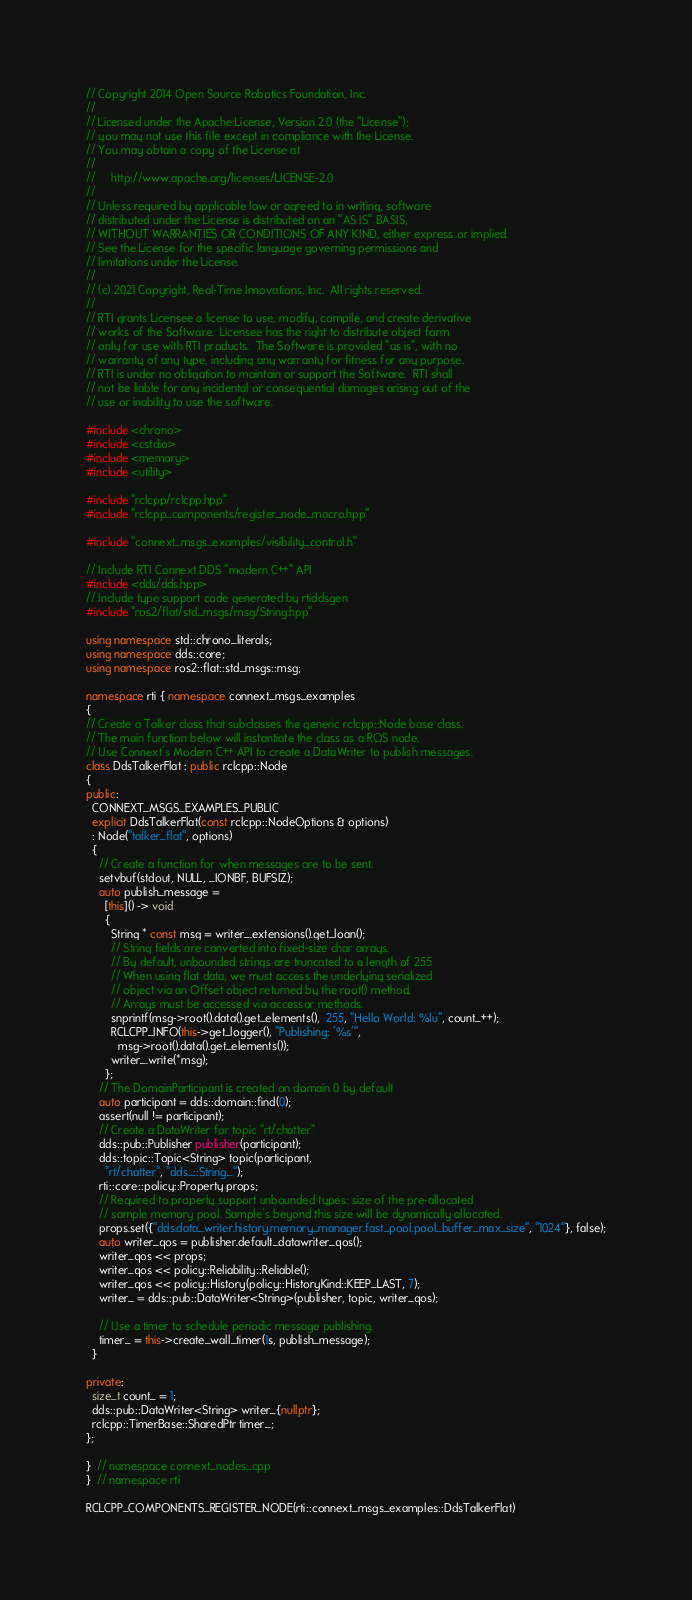<code> <loc_0><loc_0><loc_500><loc_500><_C++_>// Copyright 2014 Open Source Robotics Foundation, Inc.
//
// Licensed under the Apache License, Version 2.0 (the "License");
// you may not use this file except in compliance with the License.
// You may obtain a copy of the License at
//
//     http://www.apache.org/licenses/LICENSE-2.0
//
// Unless required by applicable law or agreed to in writing, software
// distributed under the License is distributed on an "AS IS" BASIS,
// WITHOUT WARRANTIES OR CONDITIONS OF ANY KIND, either express or implied.
// See the License for the specific language governing permissions and
// limitations under the License.
//
// (c) 2021 Copyright, Real-Time Innovations, Inc.  All rights reserved.
//
// RTI grants Licensee a license to use, modify, compile, and create derivative
// works of the Software.  Licensee has the right to distribute object form
// only for use with RTI products.  The Software is provided "as is", with no
// warranty of any type, including any warranty for fitness for any purpose.
// RTI is under no obligation to maintain or support the Software.  RTI shall
// not be liable for any incidental or consequential damages arising out of the
// use or inability to use the software.

#include <chrono>
#include <cstdio>
#include <memory>
#include <utility>

#include "rclcpp/rclcpp.hpp"
#include "rclcpp_components/register_node_macro.hpp"

#include "connext_msgs_examples/visibility_control.h"

// Include RTI Connext DDS "modern C++" API
#include <dds/dds.hpp>
// Include type support code generated by rtiddsgen
#include "ros2/flat/std_msgs/msg/String.hpp"

using namespace std::chrono_literals;
using namespace dds::core;
using namespace ros2::flat::std_msgs::msg;

namespace rti { namespace connext_msgs_examples
{
// Create a Talker class that subclasses the generic rclcpp::Node base class.
// The main function below will instantiate the class as a ROS node.
// Use Connext's Modern C++ API to create a DataWriter to publish messages.
class DdsTalkerFlat : public rclcpp::Node
{
public:
  CONNEXT_MSGS_EXAMPLES_PUBLIC
  explicit DdsTalkerFlat(const rclcpp::NodeOptions & options)
  : Node("talker_flat", options)
  {
    // Create a function for when messages are to be sent.
    setvbuf(stdout, NULL, _IONBF, BUFSIZ);
    auto publish_message =
      [this]() -> void
      {
        String * const msg = writer_.extensions().get_loan();
        // String fields are converted into fixed-size char arrays.
        // By default, unbounded strings are truncated to a length of 255
        // When using flat data, we must access the underlying serialized 
        // object via an Offset object returned by the root() method.
        // Arrays must be accessed via accessor methods.
        snprintf(msg->root().data().get_elements(),  255, "Hello World: %lu", count_++);
        RCLCPP_INFO(this->get_logger(), "Publishing: '%s'",
          msg->root().data().get_elements());
        writer_.write(*msg);
      };
    // The DomainParticipant is created on domain 0 by default
    auto participant = dds::domain::find(0);
    assert(null != participant);
    // Create a DataWriter for topic "rt/chatter"
    dds::pub::Publisher publisher(participant);
    dds::topic::Topic<String> topic(participant,
      "rt/chatter", "dds_::String_");
    rti::core::policy::Property props;
    // Required to properly support unbounded types: size of the pre-allocated
    // sample memory pool. Sample's beyond this size will be dynamically allocated.
    props.set({"dds.data_writer.history.memory_manager.fast_pool.pool_buffer_max_size", "1024"}, false);
    auto writer_qos = publisher.default_datawriter_qos(); 
    writer_qos << props;
    writer_qos << policy::Reliability::Reliable();
    writer_qos << policy::History(policy::HistoryKind::KEEP_LAST, 7);
    writer_ = dds::pub::DataWriter<String>(publisher, topic, writer_qos);

    // Use a timer to schedule periodic message publishing.
    timer_ = this->create_wall_timer(1s, publish_message);
  }

private:
  size_t count_ = 1;
  dds::pub::DataWriter<String> writer_{nullptr};
  rclcpp::TimerBase::SharedPtr timer_;
};

}  // namespace connext_nodes_cpp
}  // namespace rti

RCLCPP_COMPONENTS_REGISTER_NODE(rti::connext_msgs_examples::DdsTalkerFlat)
</code> 